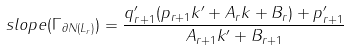Convert formula to latex. <formula><loc_0><loc_0><loc_500><loc_500>s l o p e ( \Gamma _ { \partial N ( L _ { r } ) } ) = \frac { q ^ { \prime } _ { r + 1 } ( p _ { r + 1 } k ^ { \prime } + A _ { r } k + B _ { r } ) + p ^ { \prime } _ { r + 1 } } { A _ { r + 1 } k ^ { \prime } + B _ { r + 1 } }</formula> 